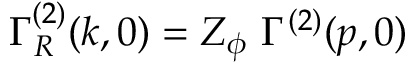<formula> <loc_0><loc_0><loc_500><loc_500>\Gamma _ { R } ^ { ( 2 ) } ( k , 0 ) = Z _ { \phi } \Gamma ^ { ( 2 ) } ( p , 0 )</formula> 